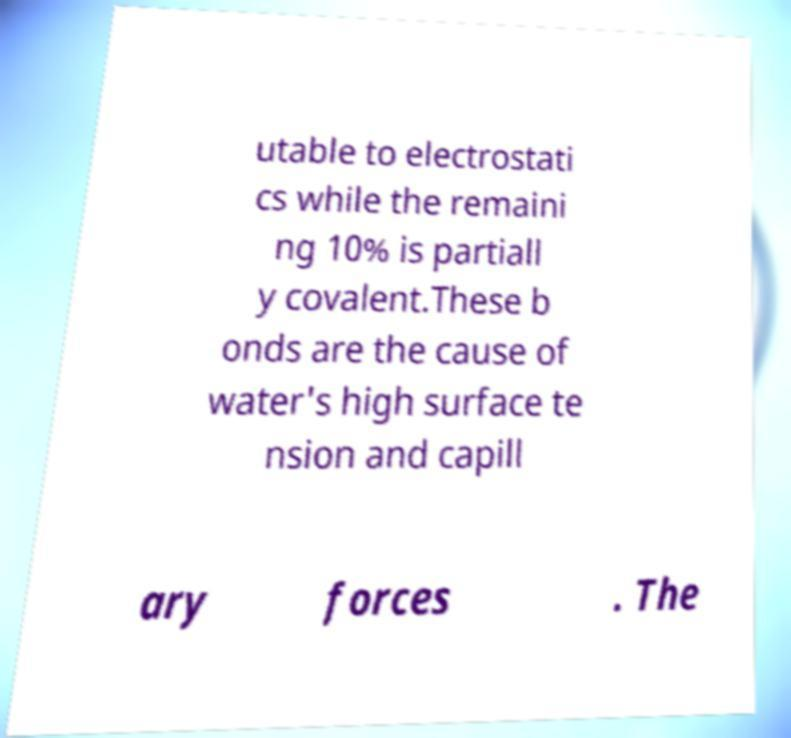Can you read and provide the text displayed in the image?This photo seems to have some interesting text. Can you extract and type it out for me? utable to electrostati cs while the remaini ng 10% is partiall y covalent.These b onds are the cause of water's high surface te nsion and capill ary forces . The 